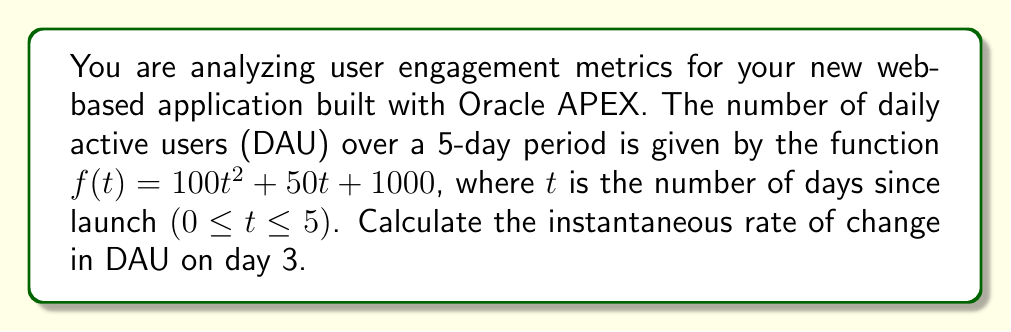Give your solution to this math problem. To find the instantaneous rate of change on day 3, we need to calculate the derivative of the function $f(t)$ and evaluate it at $t = 3$. This will give us the slope of the tangent line to the curve at that point, which represents the rate of change.

1. Given function: $f(t) = 100t^2 + 50t + 1000$

2. Calculate the derivative $f'(t)$:
   $$f'(t) = \frac{d}{dt}(100t^2 + 50t + 1000)$$
   $$f'(t) = 200t + 50$$

3. Evaluate $f'(t)$ at $t = 3$:
   $$f'(3) = 200(3) + 50$$
   $$f'(3) = 600 + 50 = 650$$

The instantaneous rate of change on day 3 is 650 users per day. This means that on the third day after launch, the number of daily active users is increasing at a rate of 650 users per day.
Answer: $650$ users per day 